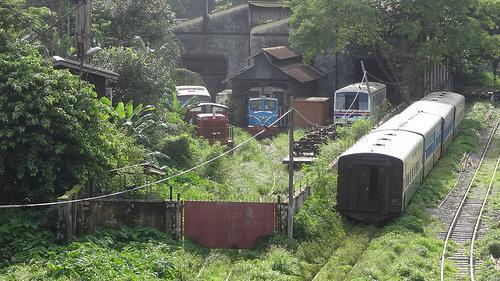How many tunnels are there?
Give a very brief answer. 2. 